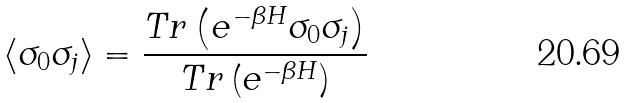Convert formula to latex. <formula><loc_0><loc_0><loc_500><loc_500>\left < \sigma _ { 0 } \sigma _ { j } \right > = \frac { T r \left ( e ^ { - \beta H } \sigma _ { 0 } \sigma _ { j } \right ) } { T r \left ( e ^ { - \beta H } \right ) }</formula> 